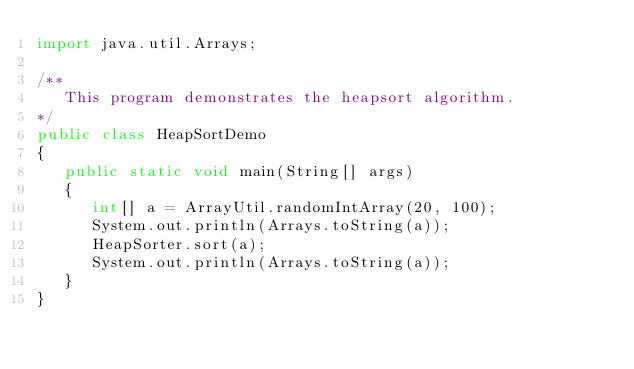Convert code to text. <code><loc_0><loc_0><loc_500><loc_500><_Java_>import java.util.Arrays;

/**
   This program demonstrates the heapsort algorithm.
*/
public class HeapSortDemo
{  
   public static void main(String[] args)
   {  
      int[] a = ArrayUtil.randomIntArray(20, 100);
      System.out.println(Arrays.toString(a));
      HeapSorter.sort(a);
      System.out.println(Arrays.toString(a));
   }
}
</code> 